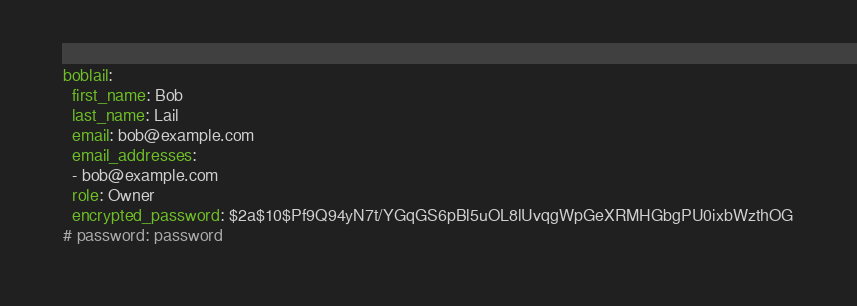Convert code to text. <code><loc_0><loc_0><loc_500><loc_500><_YAML_>boblail:
  first_name: Bob
  last_name: Lail
  email: bob@example.com
  email_addresses:
  - bob@example.com
  role: Owner
  encrypted_password: $2a$10$Pf9Q94yN7t/YGqGS6pBl5uOL8lUvqgWpGeXRMHGbgPU0ixbWzthOG
# password: password
</code> 